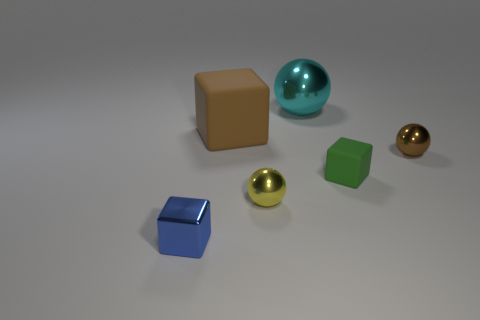Add 4 tiny matte cylinders. How many objects exist? 10 Add 3 tiny yellow things. How many tiny yellow things exist? 4 Subtract 0 red cylinders. How many objects are left? 6 Subtract all small yellow objects. Subtract all brown blocks. How many objects are left? 4 Add 4 yellow metal spheres. How many yellow metal spheres are left? 5 